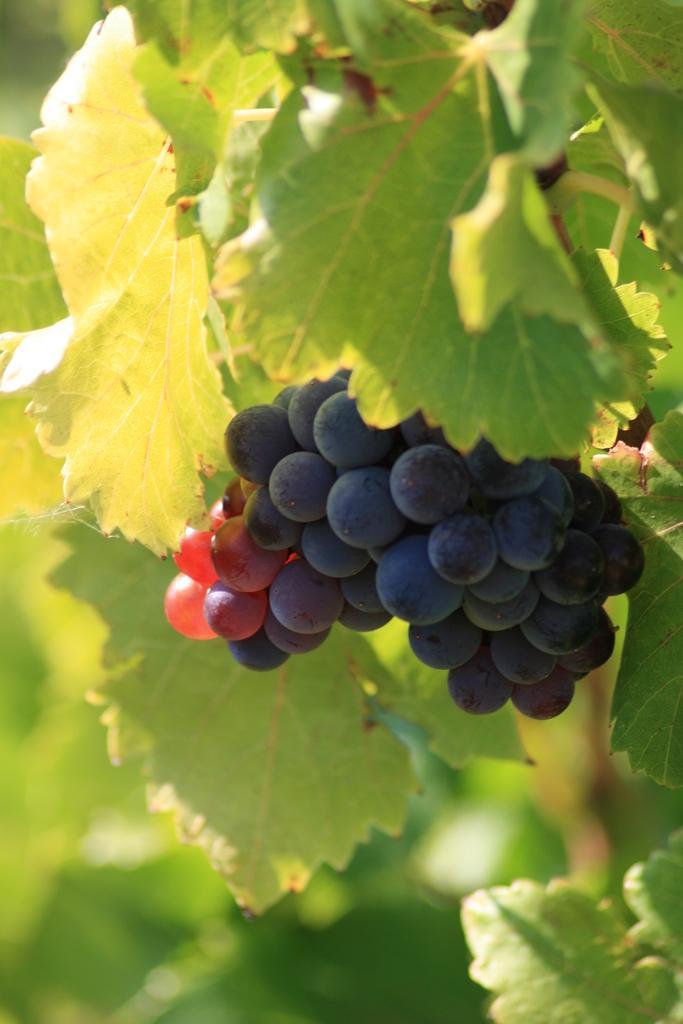Describe this image in one or two sentences. In the image there is a bunch of black grapes. And also there are green leaves. 